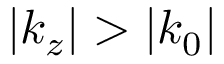Convert formula to latex. <formula><loc_0><loc_0><loc_500><loc_500>| k _ { z } | > | k _ { 0 } |</formula> 